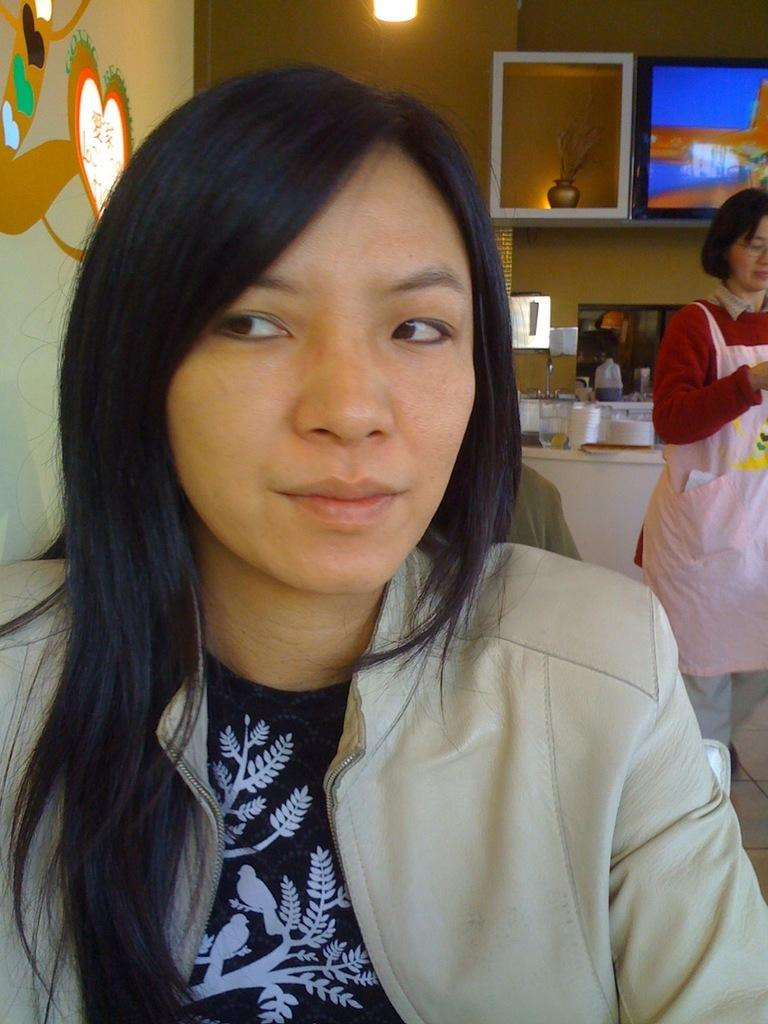Who is present in the image? There is a woman in the image. Can you describe the person in the image? There is a person in the image, and it is a woman. What can be seen in the background of the image? In the background of the image, there is a cupboard, a screen, lights, a wall, and other objects. How many people are present in the image? There is only one person present in the image, and it is a woman. What type of game is being played on the hill in the image? There is no hill or game present in the image. What kind of haircut does the woman have in the image? The image does not provide enough detail to determine the woman's haircut. 